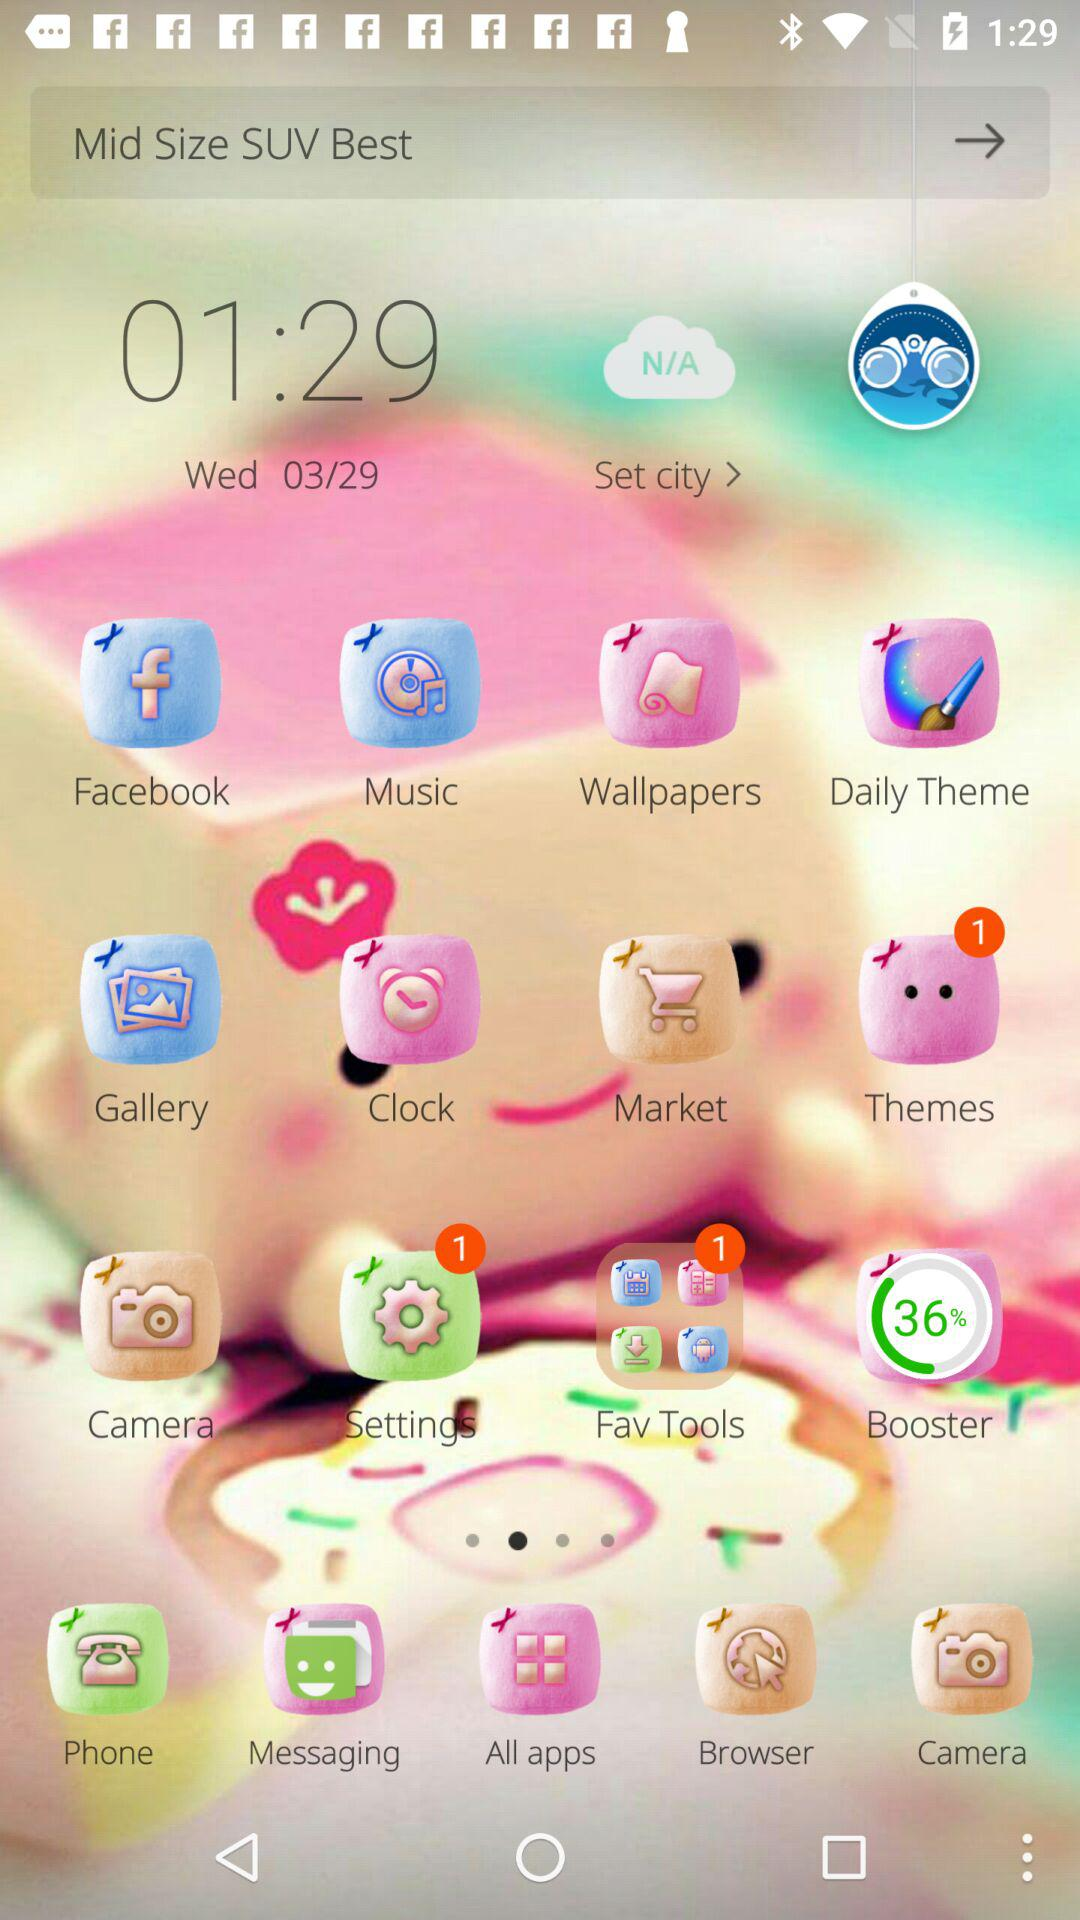What is the mentioned date? The mentioned date is Wednesday, March 29. 